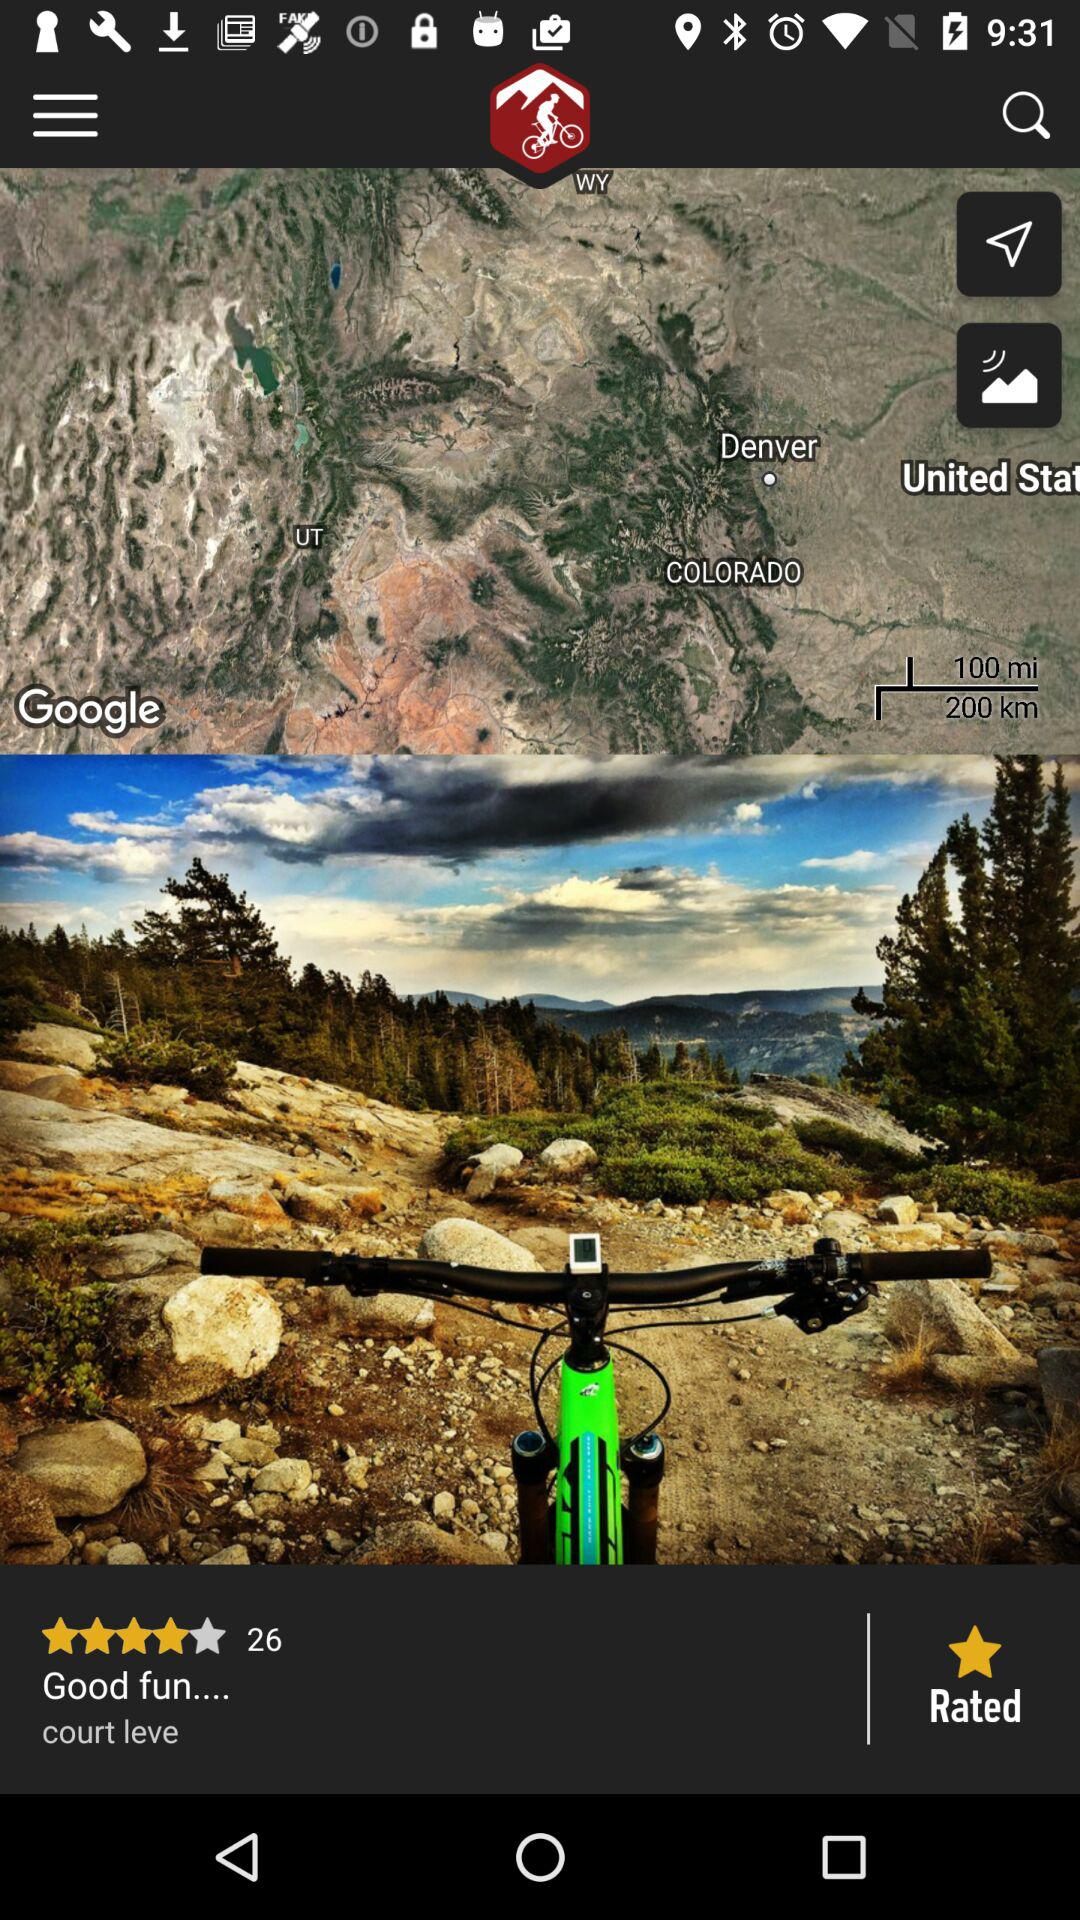How many people have rated the application? There are 26 people who have rated the application. 